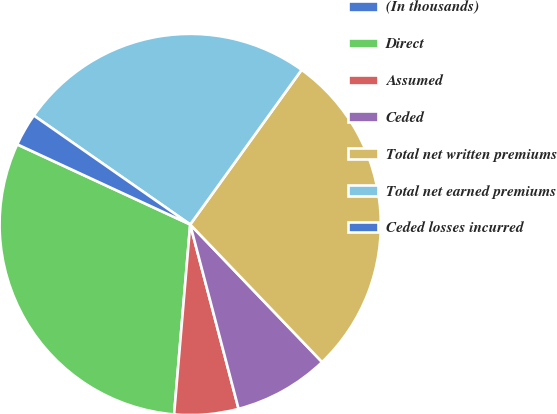Convert chart to OTSL. <chart><loc_0><loc_0><loc_500><loc_500><pie_chart><fcel>(In thousands)<fcel>Direct<fcel>Assumed<fcel>Ceded<fcel>Total net written premiums<fcel>Total net earned premiums<fcel>Ceded losses incurred<nl><fcel>0.01%<fcel>30.55%<fcel>5.43%<fcel>8.08%<fcel>27.9%<fcel>25.25%<fcel>2.78%<nl></chart> 